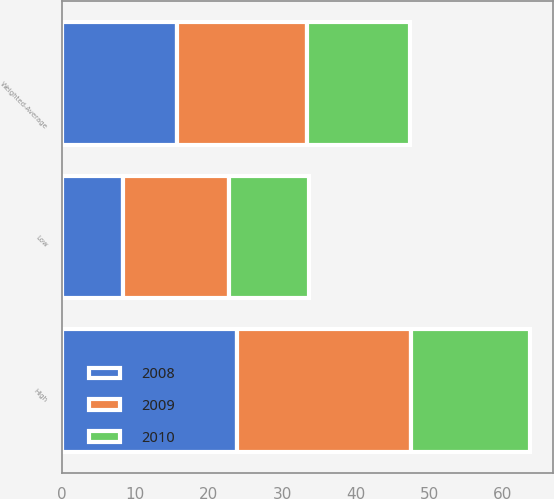Convert chart. <chart><loc_0><loc_0><loc_500><loc_500><stacked_bar_chart><ecel><fcel>Low<fcel>High<fcel>Weighted-Average<nl><fcel>2010<fcel>10.8<fcel>16.1<fcel>14<nl><fcel>2008<fcel>8.3<fcel>23.9<fcel>15.7<nl><fcel>2009<fcel>14.5<fcel>23.7<fcel>17.7<nl></chart> 